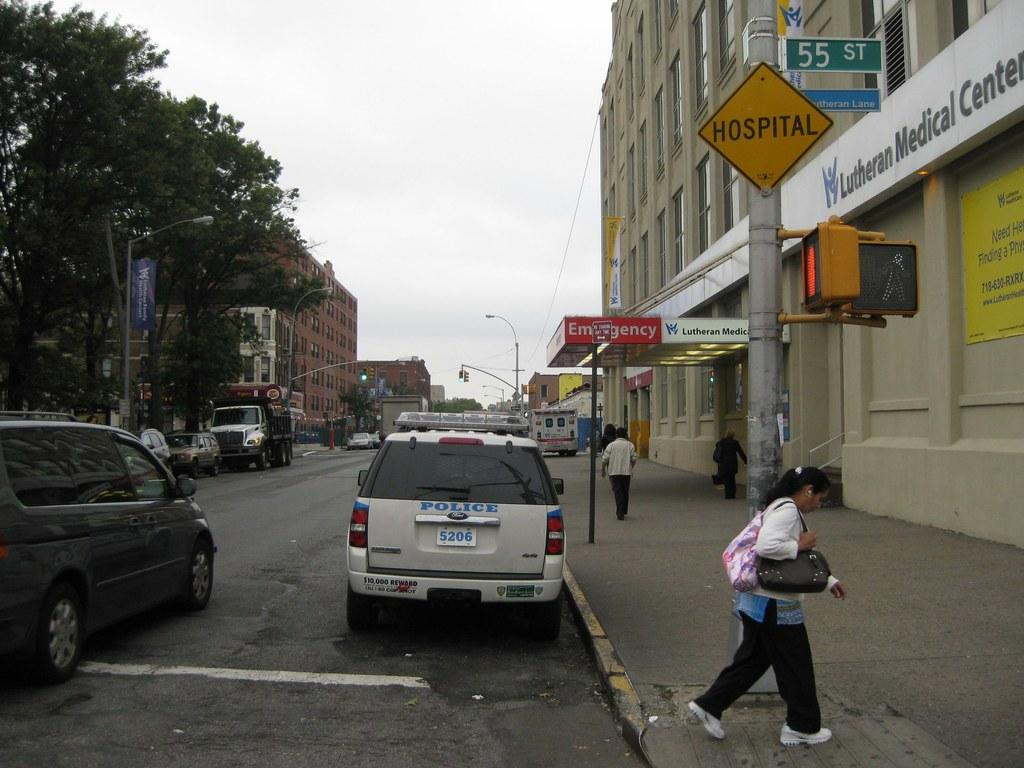<image>
Share a concise interpretation of the image provided. a street view with 55 ST on the street name sign 